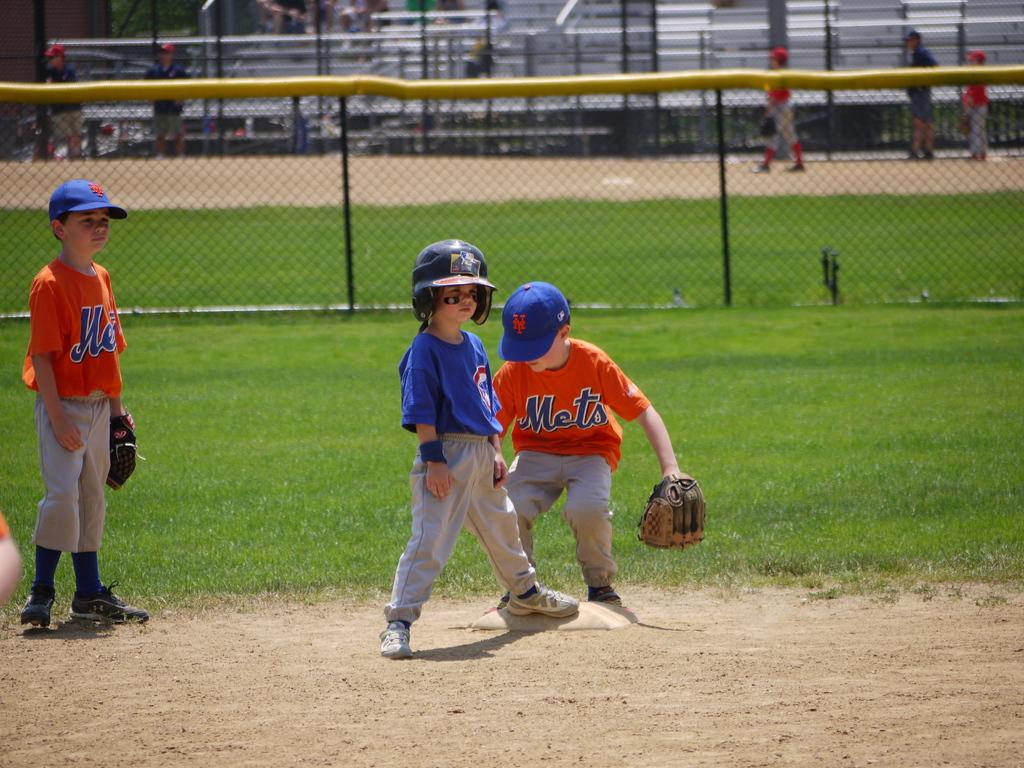Provide a one-sentence caption for the provided image. a little kid with a Mets jersey on a field. 